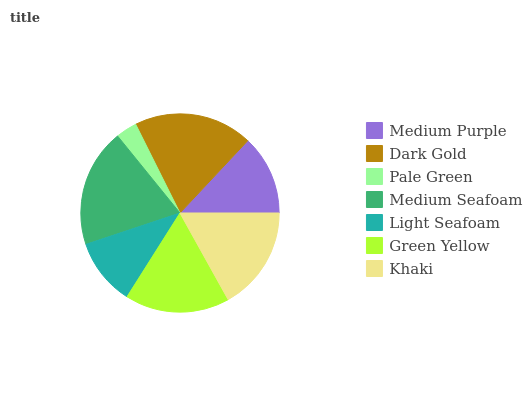Is Pale Green the minimum?
Answer yes or no. Yes. Is Dark Gold the maximum?
Answer yes or no. Yes. Is Dark Gold the minimum?
Answer yes or no. No. Is Pale Green the maximum?
Answer yes or no. No. Is Dark Gold greater than Pale Green?
Answer yes or no. Yes. Is Pale Green less than Dark Gold?
Answer yes or no. Yes. Is Pale Green greater than Dark Gold?
Answer yes or no. No. Is Dark Gold less than Pale Green?
Answer yes or no. No. Is Khaki the high median?
Answer yes or no. Yes. Is Khaki the low median?
Answer yes or no. Yes. Is Medium Seafoam the high median?
Answer yes or no. No. Is Medium Purple the low median?
Answer yes or no. No. 